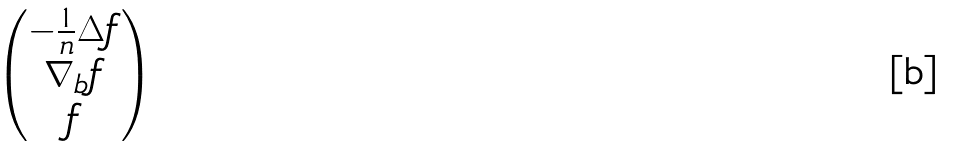<formula> <loc_0><loc_0><loc_500><loc_500>\begin{pmatrix} - \frac { 1 } { n } \Delta f \\ \nabla _ { b } f \\ f \end{pmatrix}</formula> 